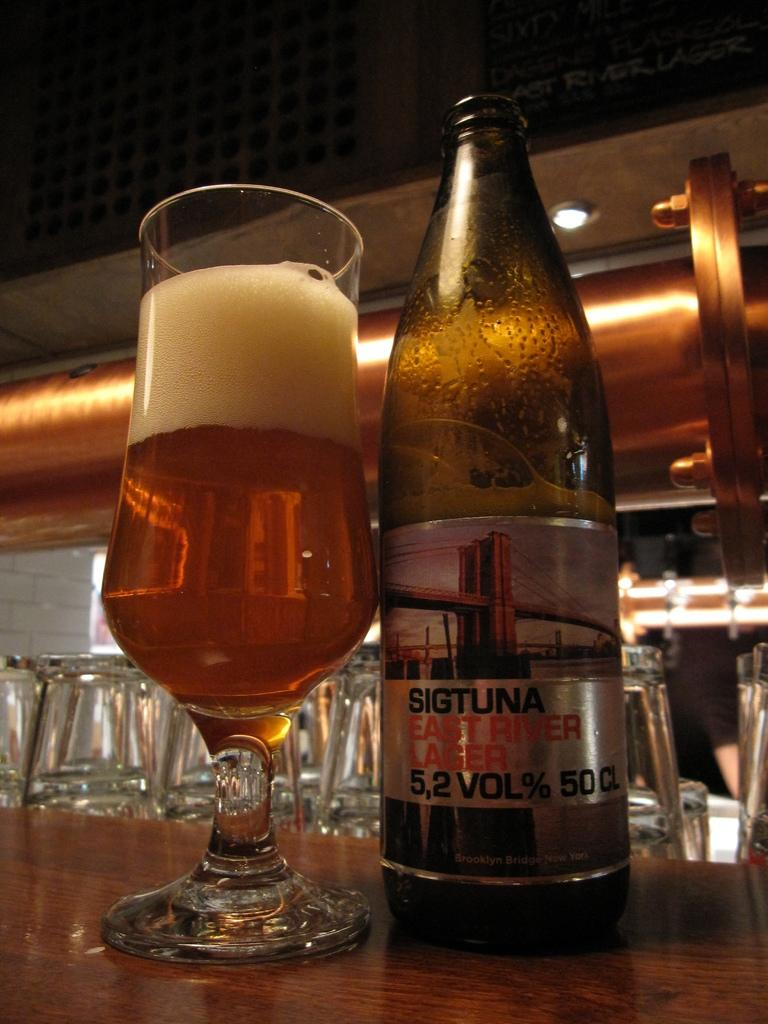<image>
Share a concise interpretation of the image provided. A bottle of Sigtuna East River Lager sits next to a glass of beer with a big head of foam. 